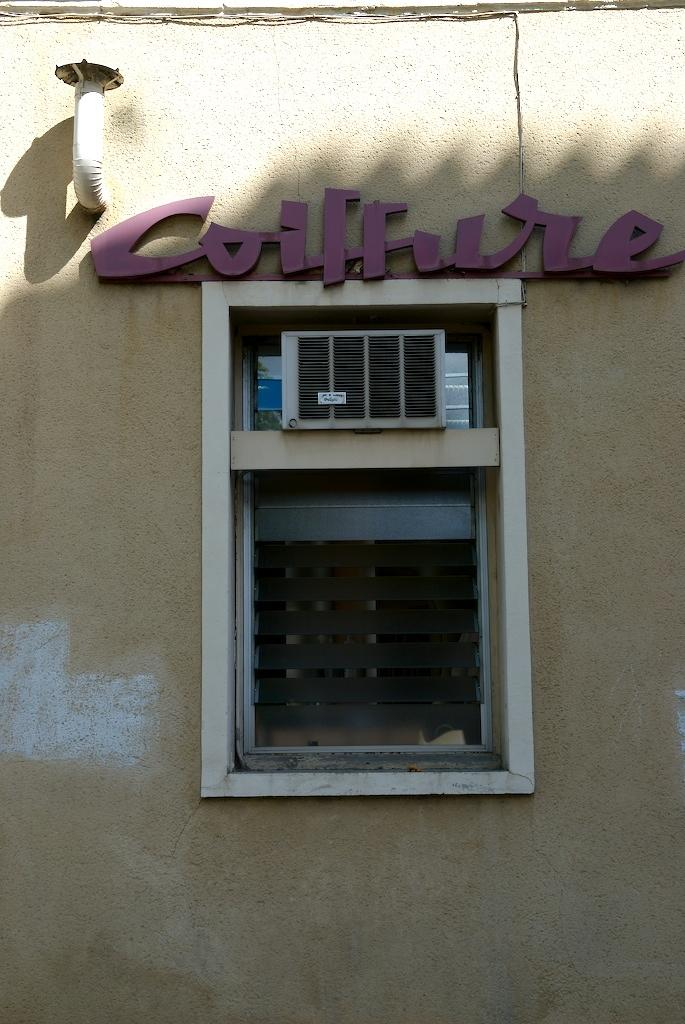What is the main structure visible in the image? There is a wall in the image. Can you describe a specific feature of the wall? There is a window in the middle of the wall. What else can be seen in the image besides the wall and window? An outdoor unit and a pipe are visible in the image. What position does the bath hold in the image? There is no bath present in the image. What type of appliance is visible in the image? The provided facts do not mention any appliances in the image. 